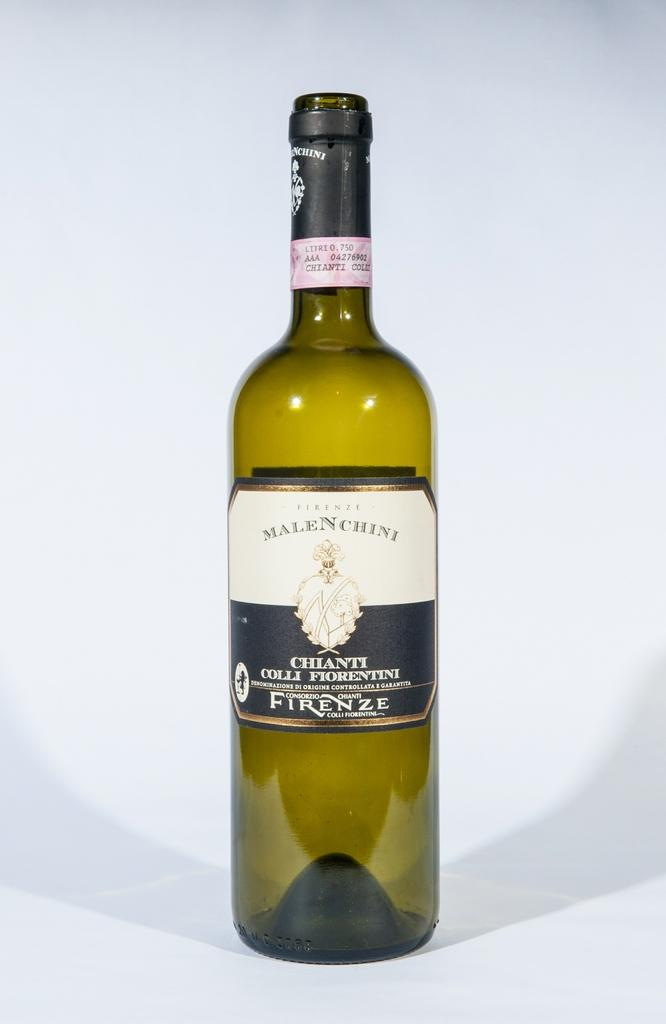<image>
Describe the image concisely. A green bottle of Malenchini chianti is on a white background. 